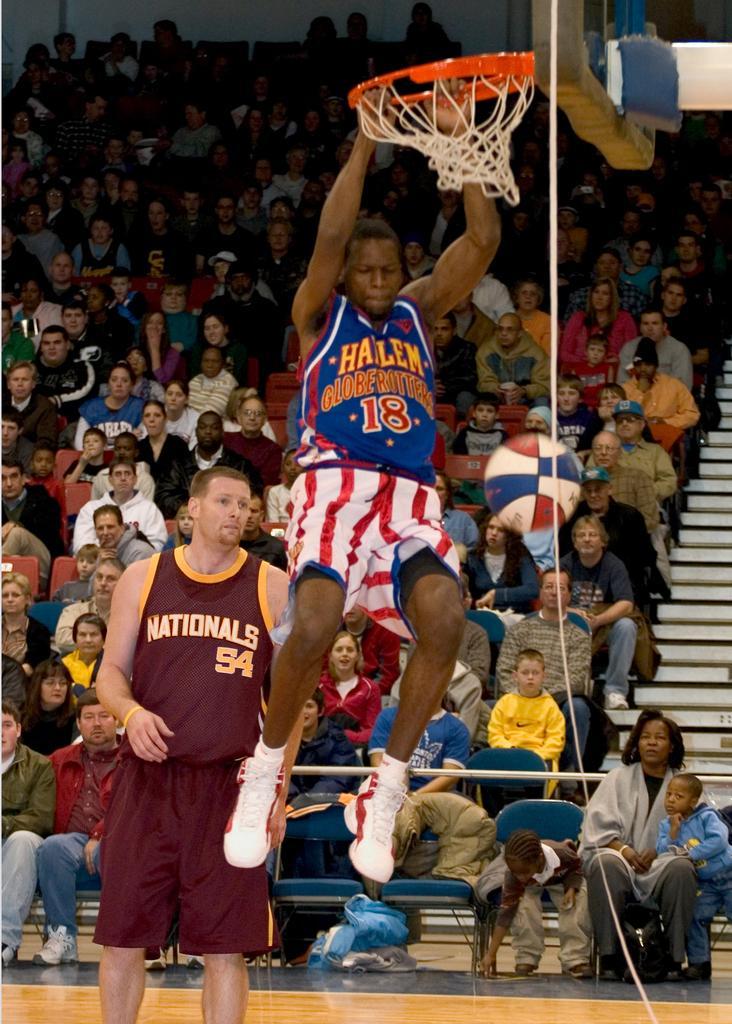Can you describe this image briefly? In this image I can see a person is hanging on the basketball net. On the left side I can see a person standing. In the background, I can see many people. 